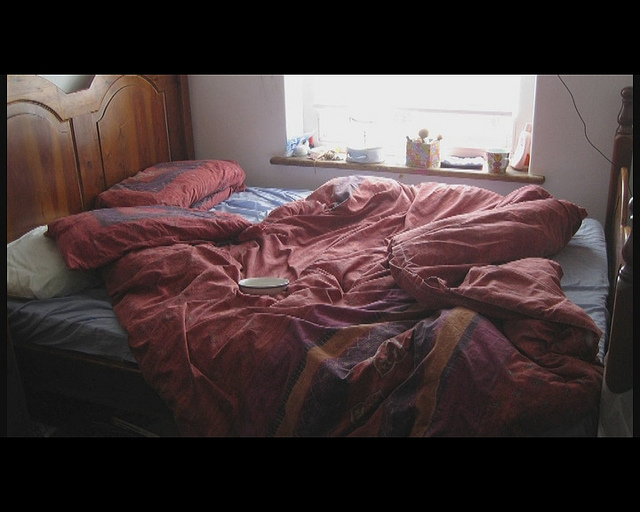<image>Why is the room so messy? I don't know why the room is messy. It could be because someone is lazy, doesn't clean up, or just got out of bed. Why is the room so messy? I don't know why the room is so messy. It could be because the person is lazy, or it could be because nobody cleaned it up. 